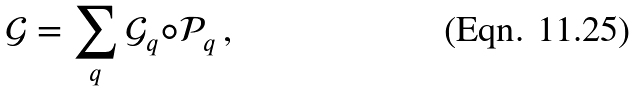<formula> <loc_0><loc_0><loc_500><loc_500>\mathcal { G } = \sum _ { q } \mathcal { G } _ { q } \circ \mathcal { P } _ { q } \, ,</formula> 